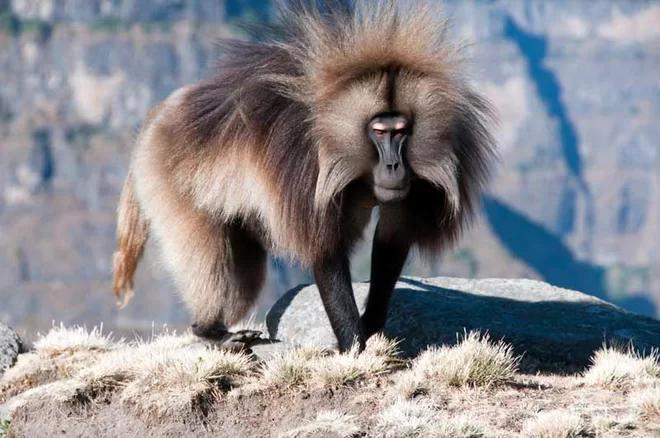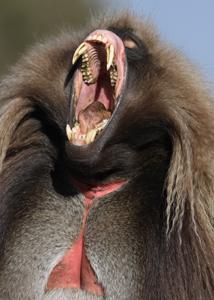The first image is the image on the left, the second image is the image on the right. Given the left and right images, does the statement "At least one baboon has a wide open mouth." hold true? Answer yes or no. Yes. The first image is the image on the left, the second image is the image on the right. Assess this claim about the two images: "in the right pic the primates fangs are fully shown". Correct or not? Answer yes or no. Yes. 